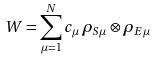<formula> <loc_0><loc_0><loc_500><loc_500>W = \sum _ { \mu = 1 } ^ { N } c _ { \mu } \, \rho _ { S \mu } \otimes \rho _ { E \mu }</formula> 